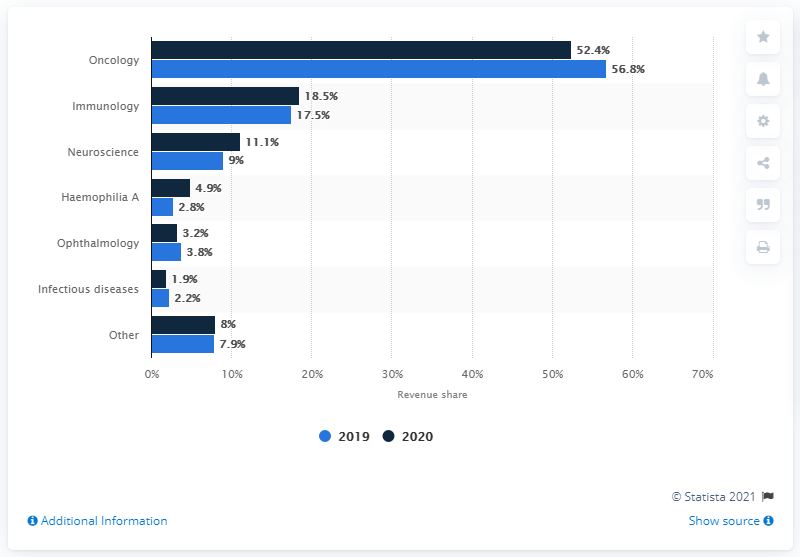Mention a couple of crucial points in this snapshot. The average revenue of infectious diseases is 2.05. In the data provided, the Oncology department had a revenue distribution greater than 50% in both years. 